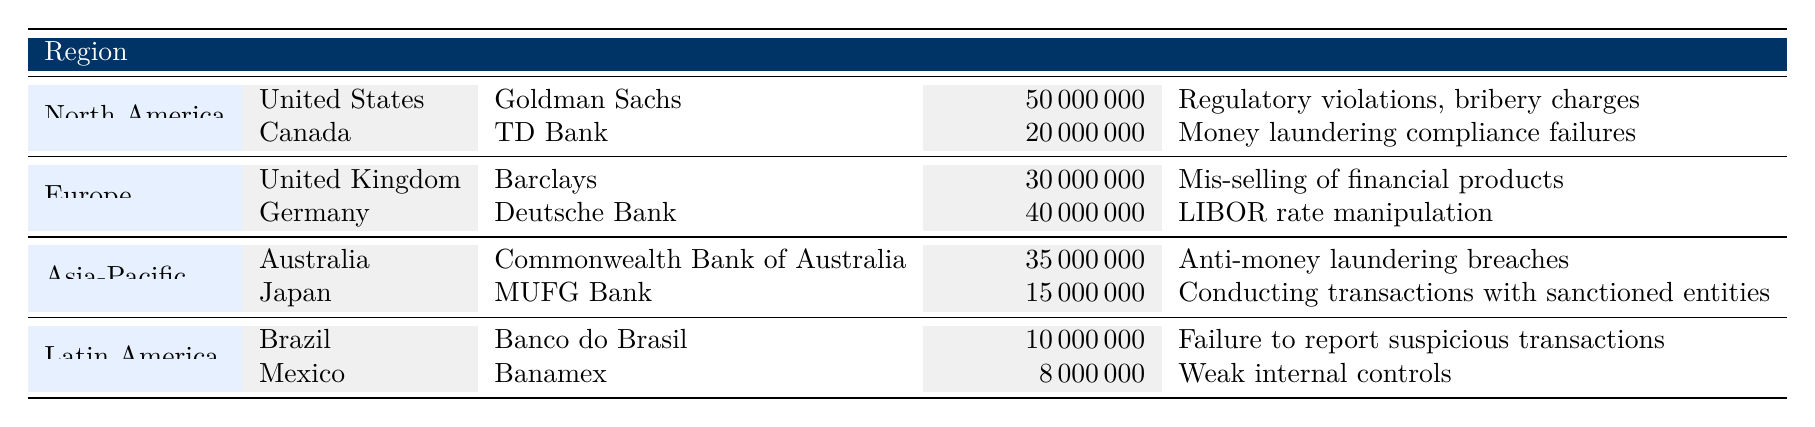What is the highest fine amount in the Asia-Pacific region? According to the table, the fine amounts for the Asia-Pacific region are 35,000,000 for Commonwealth Bank of Australia and 15,000,000 for MUFG Bank. The highest of these amounts is 35,000,000.
Answer: 35,000,000 Which country has the lowest penalty payment? The penalty payments listed are: 50,000,000 (United States), 20,000,000 (Canada), 30,000,000 (United Kingdom), 40,000,000 (Germany), 35,000,000 (Australia), 15,000,000 (Japan), 10,000,000 (Brazil), and 8,000,000 (Mexico). The lowest amount is 8,000,000, which corresponds to Banamex in Mexico.
Answer: Mexico Is the fine for TD Bank greater than the combined fines for Banco do Brasil and Banamex? The fine for TD Bank is 20,000,000. The combined fines for Banco do Brasil (10,000,000) and Banamex (8,000,000) is 18,000,000. Since 20,000,000 is greater than 18,000,000, the answer is yes.
Answer: Yes What is the total fine amount for banks in North America? The fine amounts for North America are 50,000,000 (United States) and 20,000,000 (Canada). Adding these together: 50,000,000 + 20,000,000 = 70,000,000. Thus, the total fine amount for the region is 70,000,000.
Answer: 70,000,000 Are there any banks in the table that received a fine for money laundering issues? According to the table, TD Bank received a fine for money laundering compliance failures, and Commonwealth Bank of Australia was fined for anti-money laundering breaches. Since at least one bank is mentioned for money laundering violations, the answer is yes.
Answer: Yes Which entity has the largest fine among all listed entities? From the table, the fine amounts are: 50,000,000 (Goldman Sachs), 20,000,000 (TD Bank), 30,000,000 (Barclays), 40,000,000 (Deutsche Bank), 35,000,000 (Commonwealth Bank of Australia), 15,000,000 (MUFG Bank), 10,000,000 (Banco do Brasil), and 8,000,000 (Banamex). The largest fine is 50,000,000 for Goldman Sachs.
Answer: Goldman Sachs 